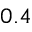Convert formula to latex. <formula><loc_0><loc_0><loc_500><loc_500>0 . 4</formula> 